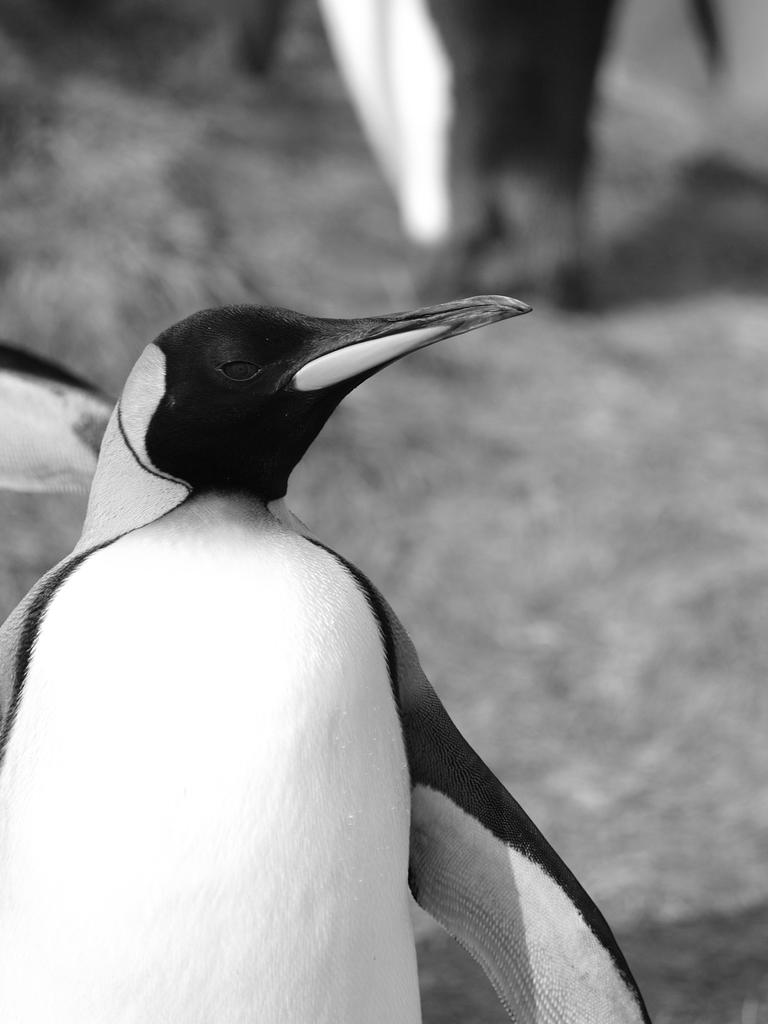What type of animal is in the image? There is a penguin in the image. What type of cracker is the penguin using to force open the door on the side of the image? There is no cracker, force, or door present in the image; it only features a penguin. 